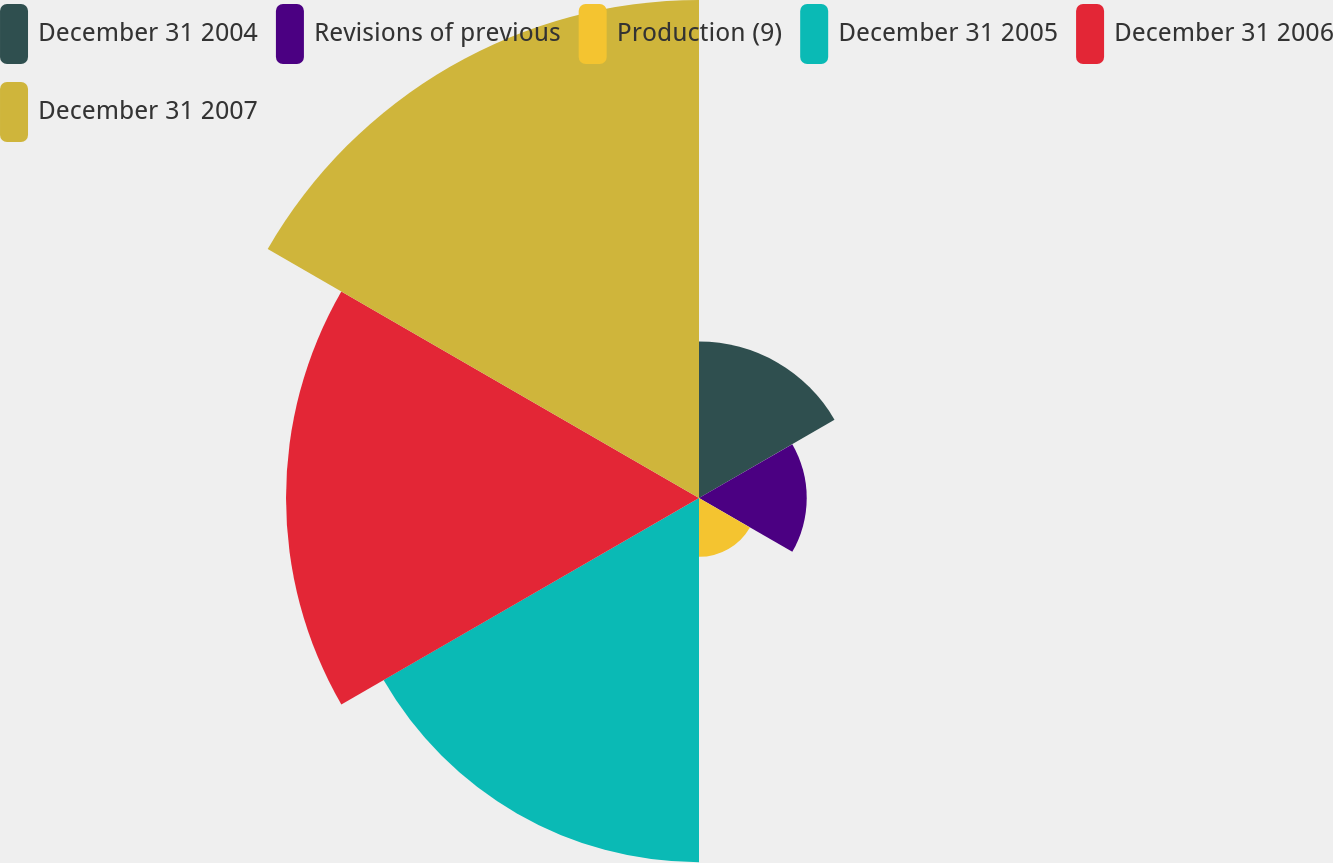Convert chart to OTSL. <chart><loc_0><loc_0><loc_500><loc_500><pie_chart><fcel>December 31 2004<fcel>Revisions of previous<fcel>Production (9)<fcel>December 31 2005<fcel>December 31 2006<fcel>December 31 2007<nl><fcel>9.79%<fcel>6.74%<fcel>3.68%<fcel>22.79%<fcel>25.84%<fcel>31.16%<nl></chart> 